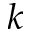<formula> <loc_0><loc_0><loc_500><loc_500>k</formula> 